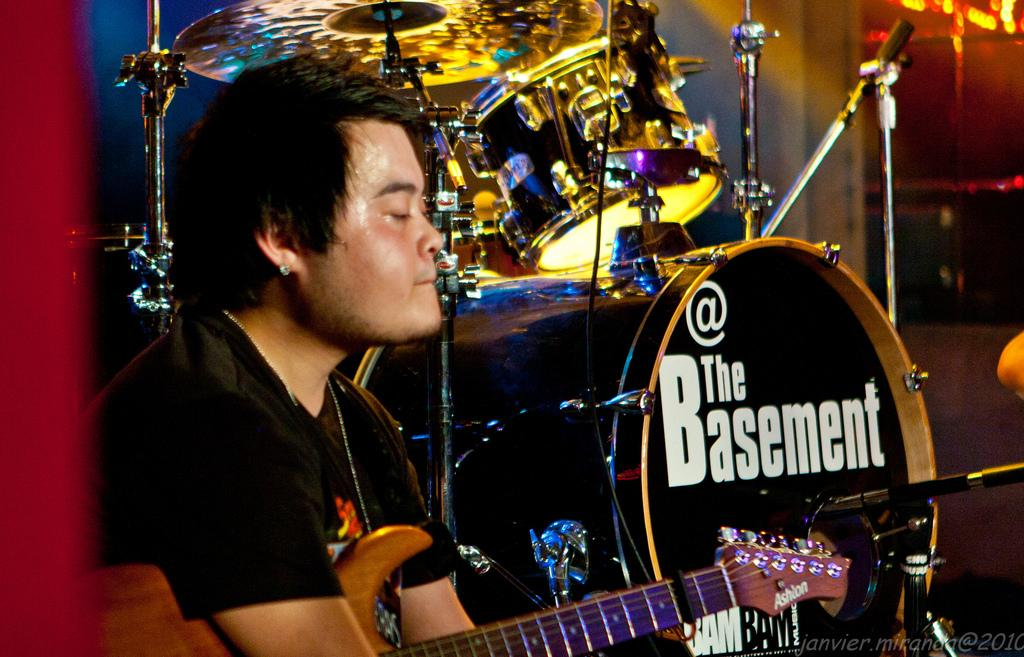Who is present in the image? There is a man in the image. Where is the man located in the image? The man is on the left side of the image. What is the man holding in his hand? The man is holding a guitar in his hand. What can be seen in the background of the image? There is a musical instrument in the background of the image. What is written on the musical instrument? The word "@ the basement" is written on the musical instrument. Is the man wearing a mask in the image? There is no mention of a mask in the image, so we cannot determine if the man is wearing one. 